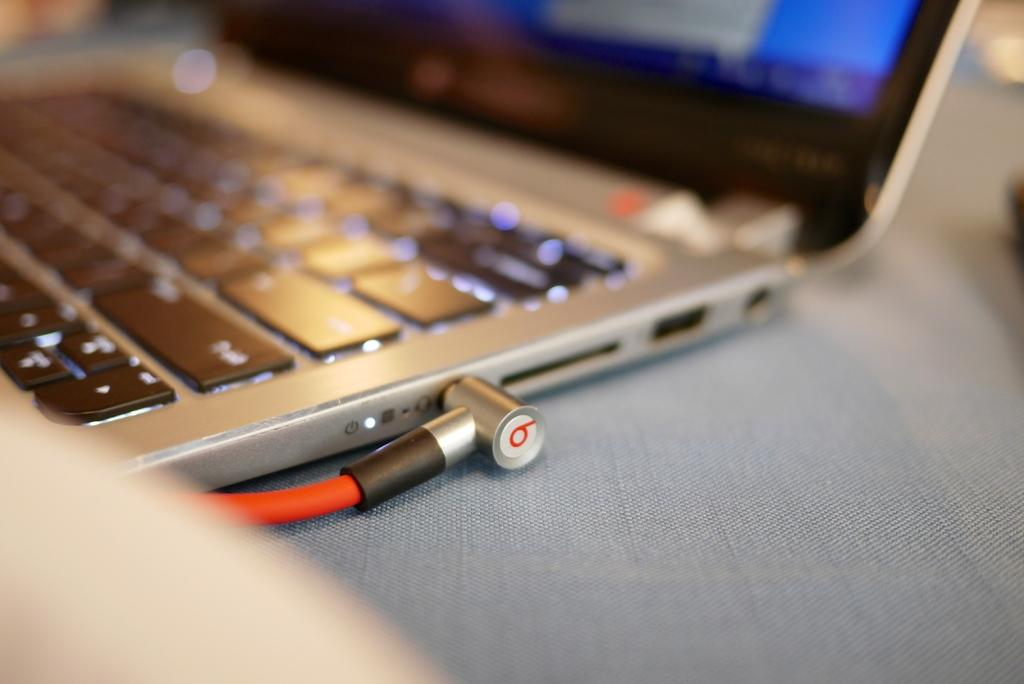Provide a one-sentence caption for the provided image. The wire connected to the computer is labeled with the number 6. 